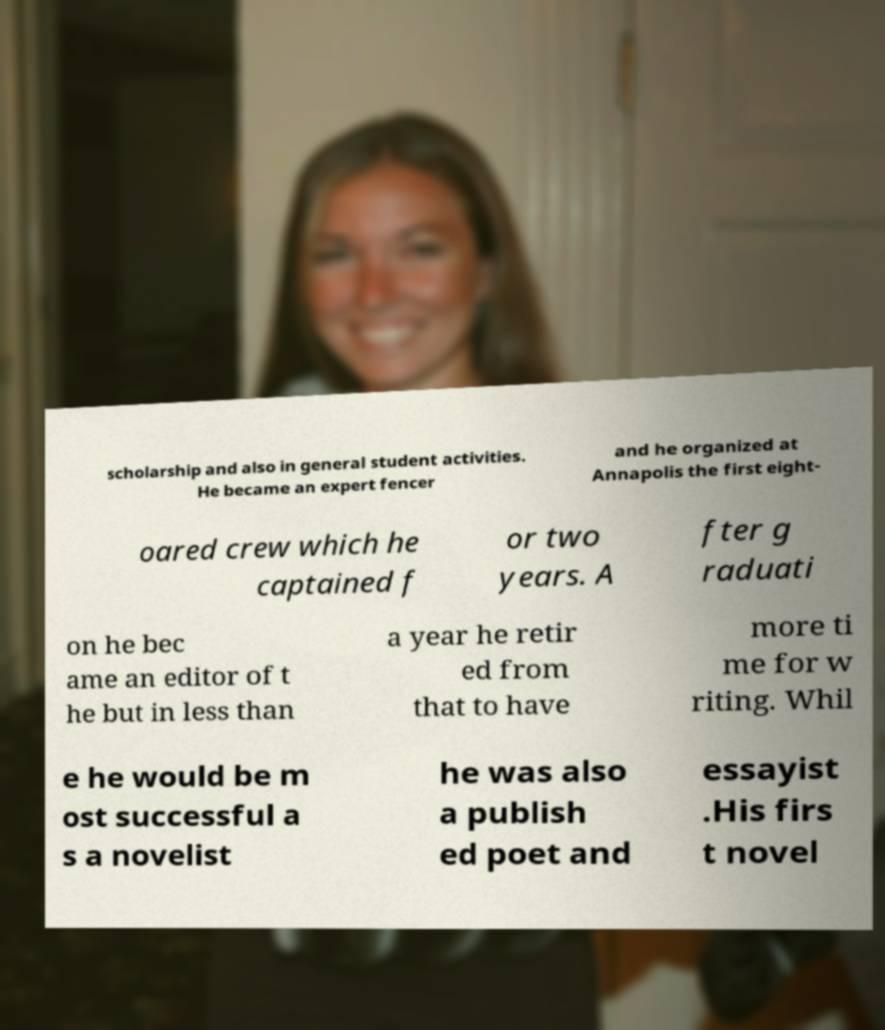Could you assist in decoding the text presented in this image and type it out clearly? scholarship and also in general student activities. He became an expert fencer and he organized at Annapolis the first eight- oared crew which he captained f or two years. A fter g raduati on he bec ame an editor of t he but in less than a year he retir ed from that to have more ti me for w riting. Whil e he would be m ost successful a s a novelist he was also a publish ed poet and essayist .His firs t novel 